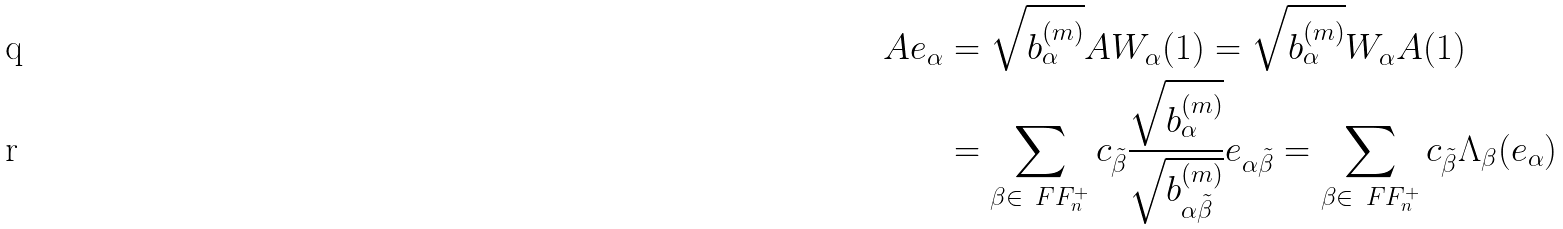<formula> <loc_0><loc_0><loc_500><loc_500>A e _ { \alpha } & = \sqrt { b _ { \alpha } ^ { ( m ) } } A W _ { \alpha } ( 1 ) = \sqrt { b _ { \alpha } ^ { ( m ) } } W _ { \alpha } A ( 1 ) \\ & = \sum _ { \beta \in \ F F _ { n } ^ { + } } c _ { \tilde { \beta } } \frac { \sqrt { b ^ { ( m ) } _ { \alpha } } } { \sqrt { b ^ { ( m ) } _ { \alpha \tilde { \beta } } } } e _ { \alpha \tilde { \beta } } = \sum _ { \beta \in \ F F _ { n } ^ { + } } c _ { \tilde { \beta } } \Lambda _ { \beta } ( e _ { \alpha } )</formula> 